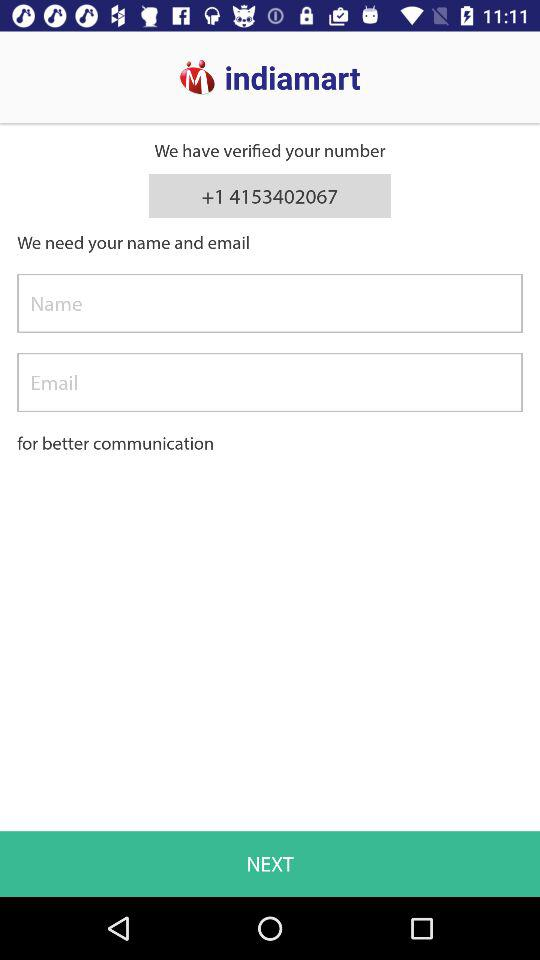What number is verified? The verified number is +1 4153402067. 